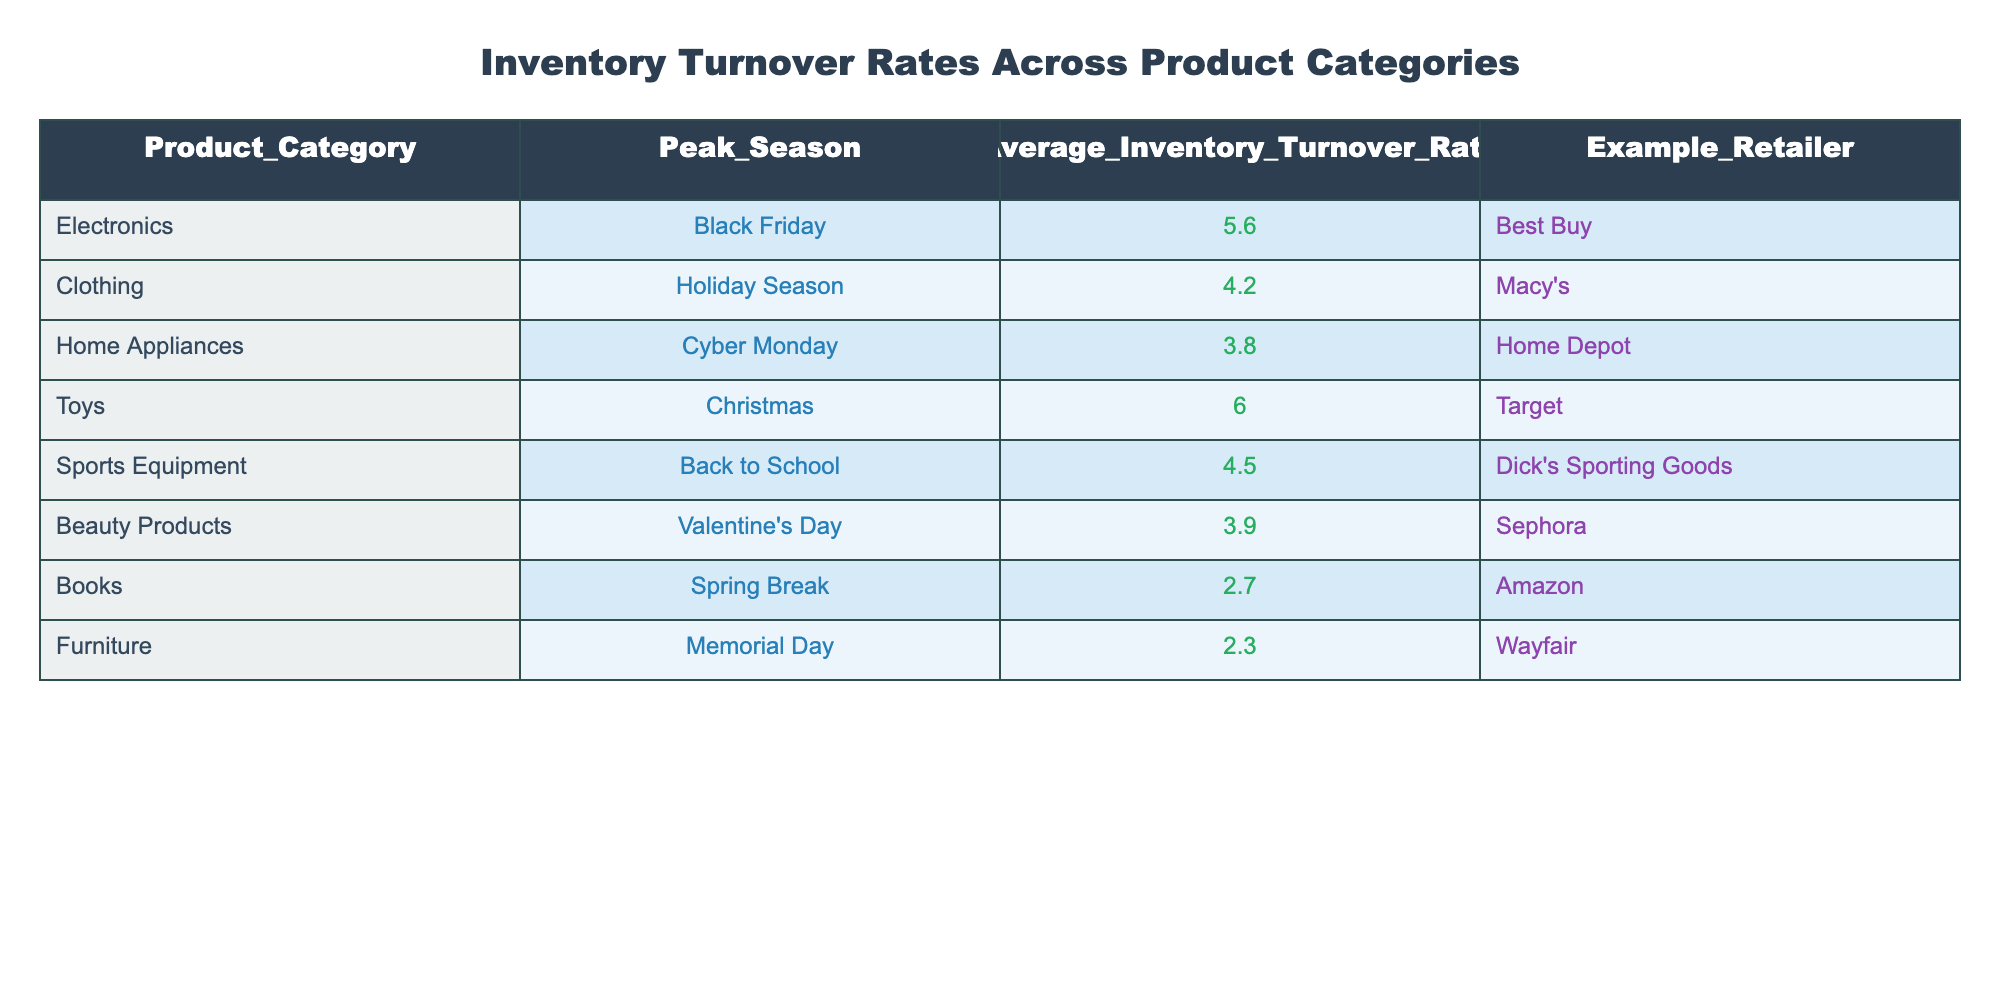What is the average inventory turnover rate for beauty products during Valentine’s Day? The table indicates that the average inventory turnover rate for beauty products during Valentine’s Day is 3.9.
Answer: 3.9 Which product category has the highest inventory turnover rate during peak shopping seasons? According to the table, the product category with the highest inventory turnover rate is Toys during Christmas, with a rate of 6.0.
Answer: Toys Is the average inventory turnover rate for home appliances greater than that for clothing during their respective peak seasons? The average inventory turnover rate for home appliances is 3.8, while for clothing it is 4.2. Since 3.8 is not greater than 4.2, the answer is no.
Answer: No What is the total inventory turnover rate when combining electronics and sports equipment? The average inventory turnover rate for electronics is 5.6 and for sports equipment, it is 4.5. The total is calculated as 5.6 + 4.5 = 10.1.
Answer: 10.1 What is the average inventory turnover rate for all product categories listed in the table? The average is calculated by summing all the inventory turnover rates: (5.6 + 4.2 + 3.8 + 6.0 + 4.5 + 3.9 + 2.7 + 2.3) = 33.0, then dividing by the number of categories (8), resulting in an average of 33.0 / 8 = 4.125.
Answer: 4.125 Are there any product categories that have an average inventory turnover rate below 3.0? From the table, both Furniture (2.3) and Books (2.7) have an inventory turnover rate below 3.0. Thus, the answer is yes.
Answer: Yes 